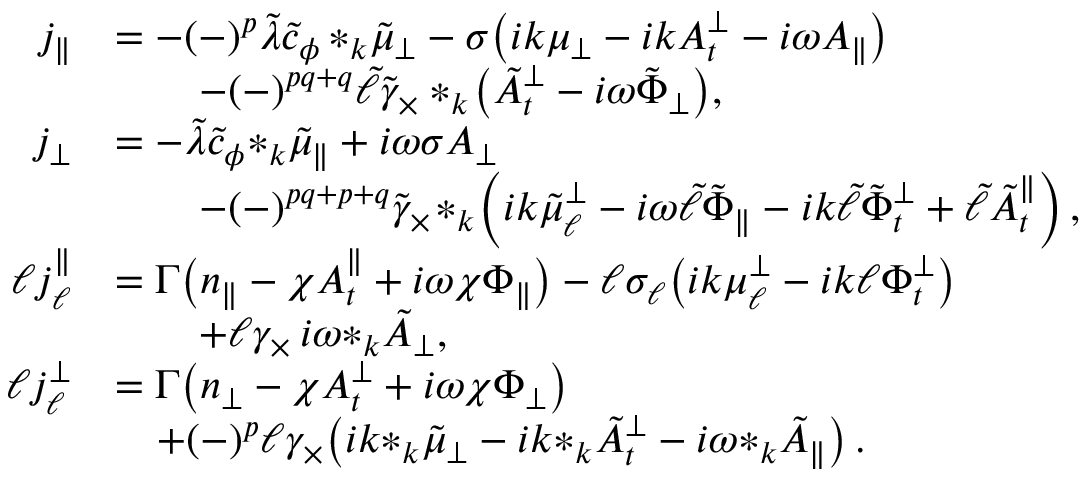<formula> <loc_0><loc_0><loc_500><loc_500>\begin{array} { r l } { j _ { \| } } & { = - ( - ) ^ { p } \tilde { \lambda } \tilde { c } _ { \phi } \, { * _ { k } \tilde { \mu } _ { \perp } } - \sigma \left ( i k { \mu _ { \perp } } - i k A _ { t } ^ { \perp } - i \omega A _ { \| } \right ) } \\ & { \quad - ( - ) ^ { p q + q } \tilde { \ell } \tilde { \gamma } _ { \times } * _ { k } \, \left ( \tilde { A } _ { t } ^ { \perp } - i \omega \tilde { \Phi } _ { \perp } \right ) , } \\ { j _ { \perp } } & { = - \tilde { \lambda } \tilde { c } _ { \phi } { * _ { k } \tilde { \mu } _ { \| } } + i \omega \sigma A _ { \perp } } \\ & { \quad - ( - ) ^ { p q + p + q } \tilde { \gamma } _ { \times } \, * _ { k } \, \left ( i k { \tilde { \mu } _ { \ell } ^ { \perp } } - i \omega \tilde { \ell } \tilde { \Phi } _ { \| } - i k \tilde { \ell } \tilde { \Phi } _ { t } ^ { \perp } + \tilde { \ell } { \tilde { A } _ { t } ^ { \| } } \right ) , } \\ { \ell j _ { \ell } ^ { \| } } & { = \Gamma \left ( n _ { \| } - \chi A _ { t } ^ { \| } + i \omega \chi \Phi _ { \| } \right ) - \ell \sigma _ { \ell } \left ( i k \mu _ { \ell } ^ { \perp } - i k \ell \Phi _ { t } ^ { \perp } \right ) } \\ & { \quad + \ell \gamma _ { \times } \, i \omega { * _ { k } \tilde { A } _ { \perp } } , } \\ { \ell j _ { \ell } ^ { \perp } } & { = \Gamma \left ( n _ { \perp } - \chi A _ { t } ^ { \perp } + i \omega \chi \Phi _ { \perp } \right ) } \\ & { \quad + ( - ) ^ { p } \ell \gamma _ { \times } \, \left ( i k { * _ { k } \tilde { \mu } _ { \perp } } - i k { * _ { k } \tilde { A } _ { t } ^ { \perp } } - i \omega { * _ { k } \tilde { A } _ { \| } } \right ) . } \end{array}</formula> 